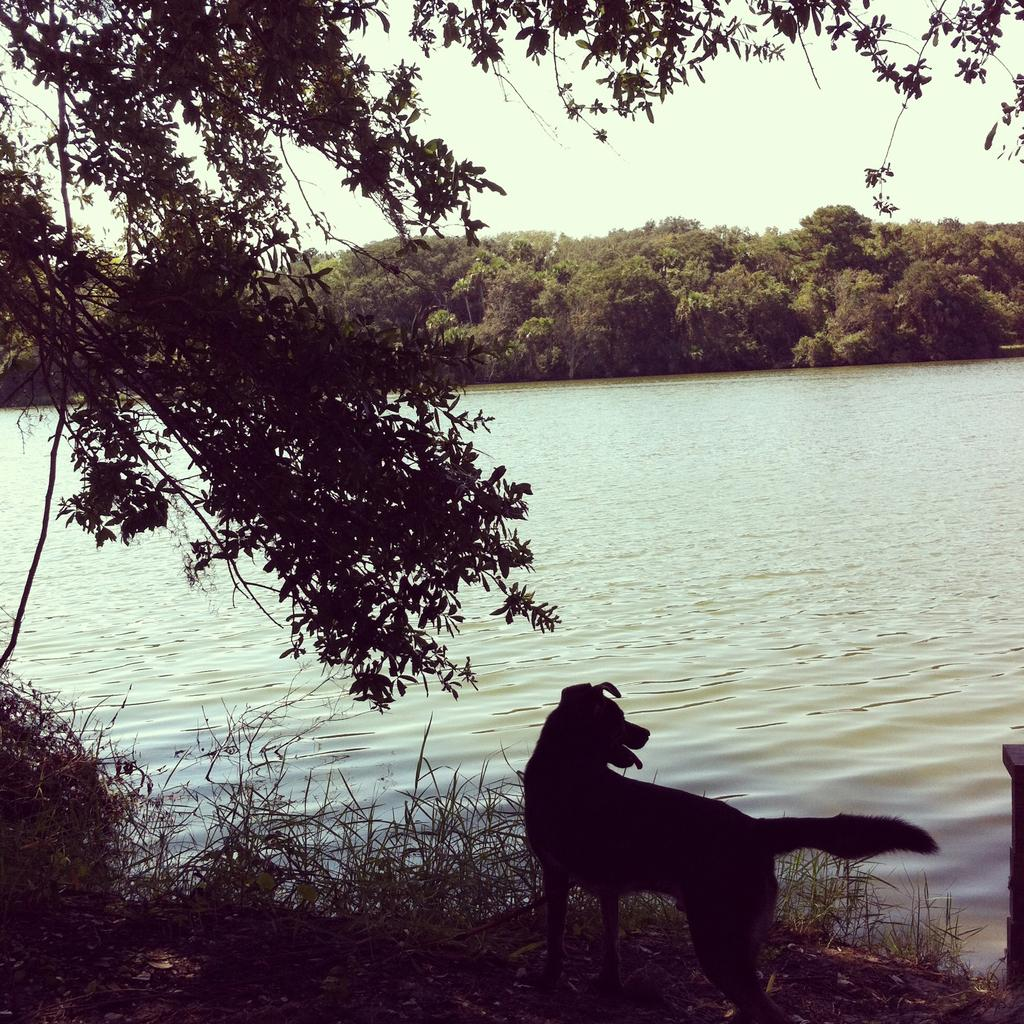What type of animal can be seen in the image? There is a dog in the image. What type of terrain is visible in the image? There is grass in the image. What body of water is present in the image? There is a river in the image. What type of vegetation is present in the image? There are trees in the image. What part of the natural environment is visible in the image? The sky is visible in the image. How many frogs are sitting on the dog's head in the image? There are no frogs present in the image, and therefore none are sitting on the dog's head. 